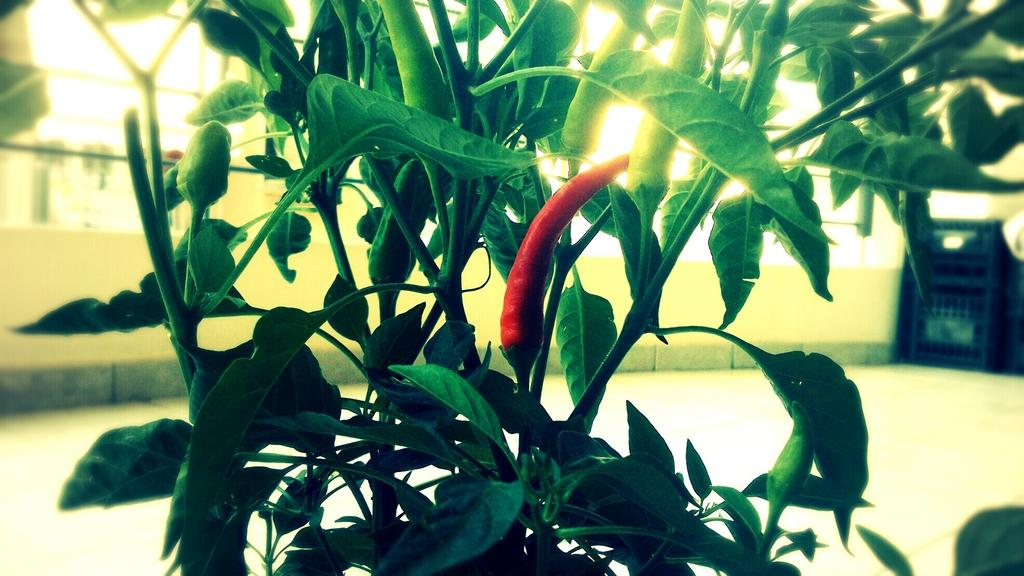What type of food item is present in the image? There are chillies in the image. What else can be seen in the image besides the chillies? There is a plant in the image. Can you describe the background of the image? The background of the image is blurry. How does the plant cast a grain in the image? There is no mention of a grain or the plant casting anything in the image. The plant is simply present in the image. 